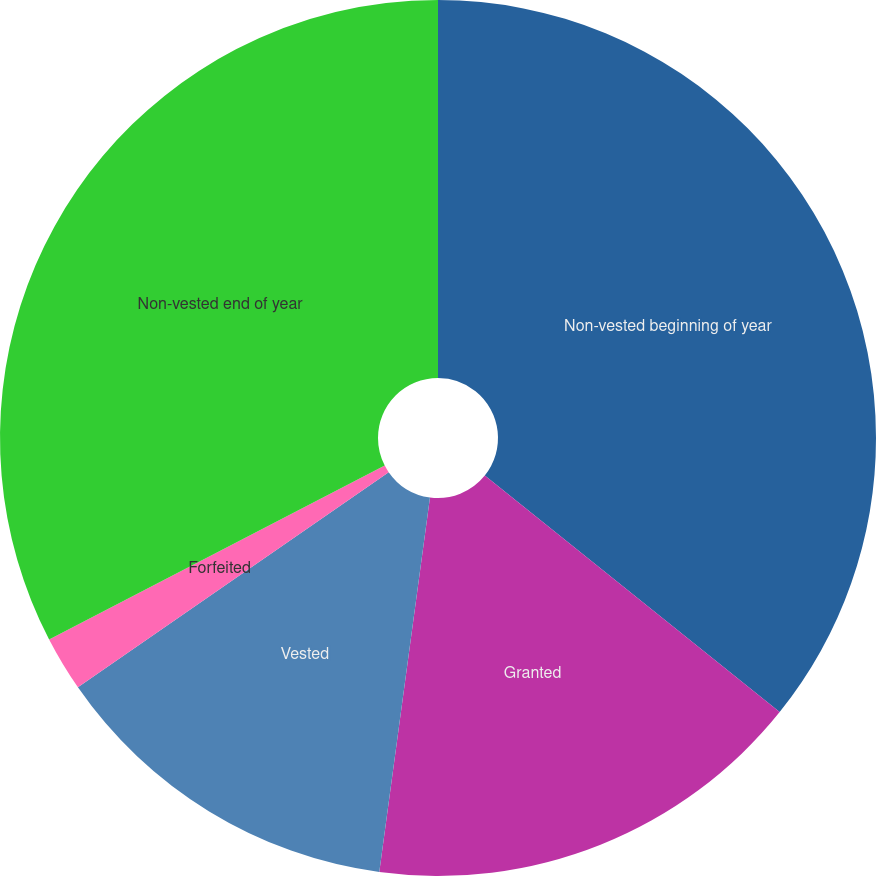Convert chart to OTSL. <chart><loc_0><loc_0><loc_500><loc_500><pie_chart><fcel>Non-vested beginning of year<fcel>Granted<fcel>Vested<fcel>Forfeited<fcel>Non-vested end of year<nl><fcel>35.76%<fcel>16.38%<fcel>13.22%<fcel>2.03%<fcel>32.61%<nl></chart> 